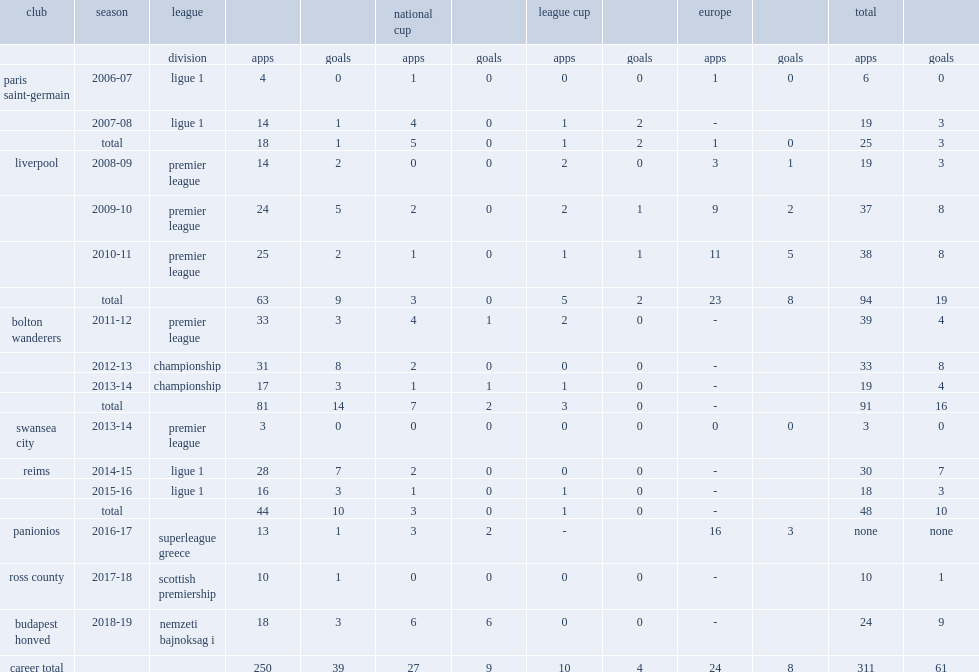Which league did david n'gog appear club liverpool in the 2008-09 season? Premier league. 